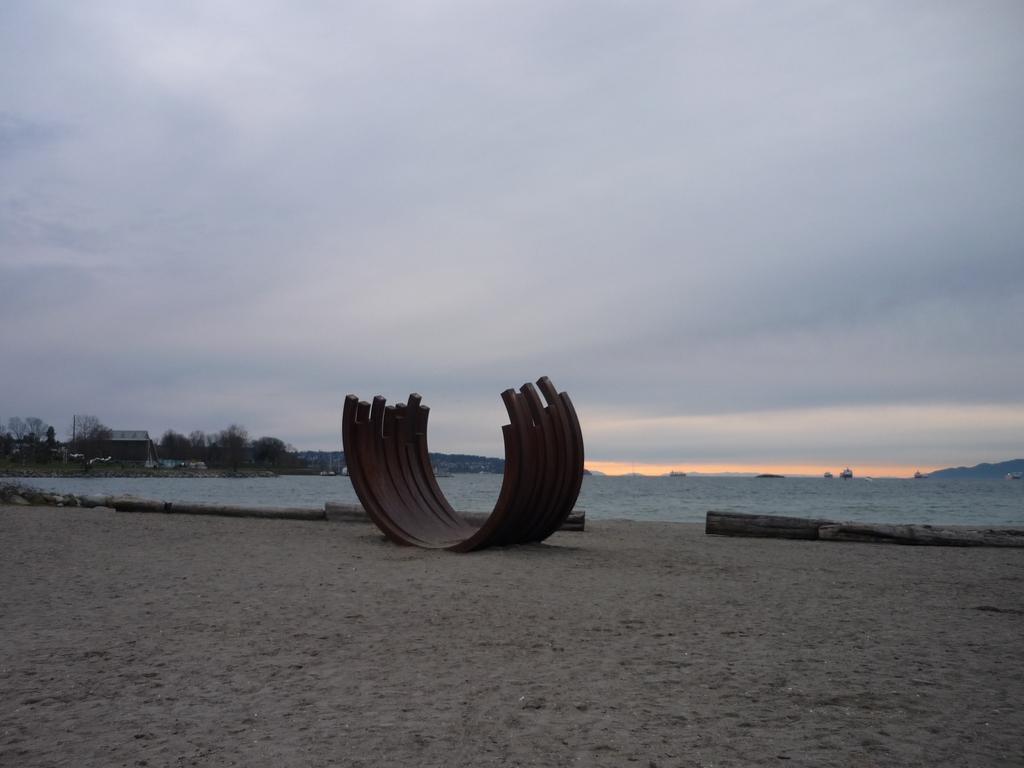Can you describe this image briefly? In this image we can see sculpture and wooden logs on the seashore, sea, buildings, trees, hills, ships on the water and sky with clouds. 